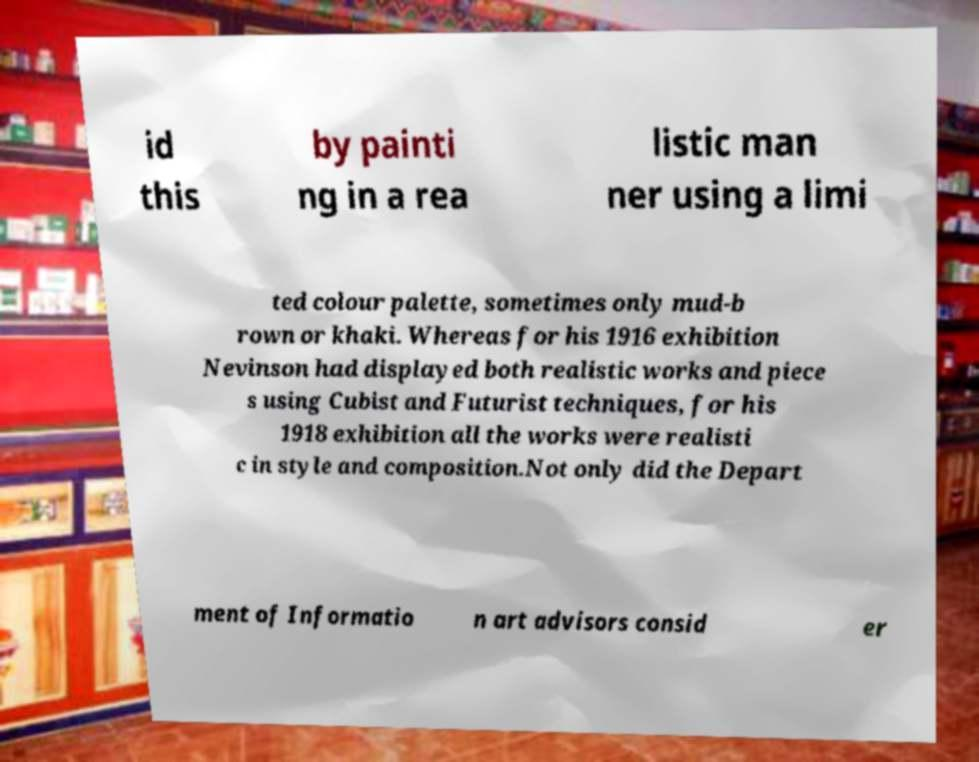Please read and relay the text visible in this image. What does it say? id this by painti ng in a rea listic man ner using a limi ted colour palette, sometimes only mud-b rown or khaki. Whereas for his 1916 exhibition Nevinson had displayed both realistic works and piece s using Cubist and Futurist techniques, for his 1918 exhibition all the works were realisti c in style and composition.Not only did the Depart ment of Informatio n art advisors consid er 